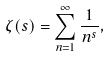<formula> <loc_0><loc_0><loc_500><loc_500>\zeta ( s ) = \sum _ { n = 1 } ^ { \infty } { \frac { 1 } { n ^ { s } } } ,</formula> 